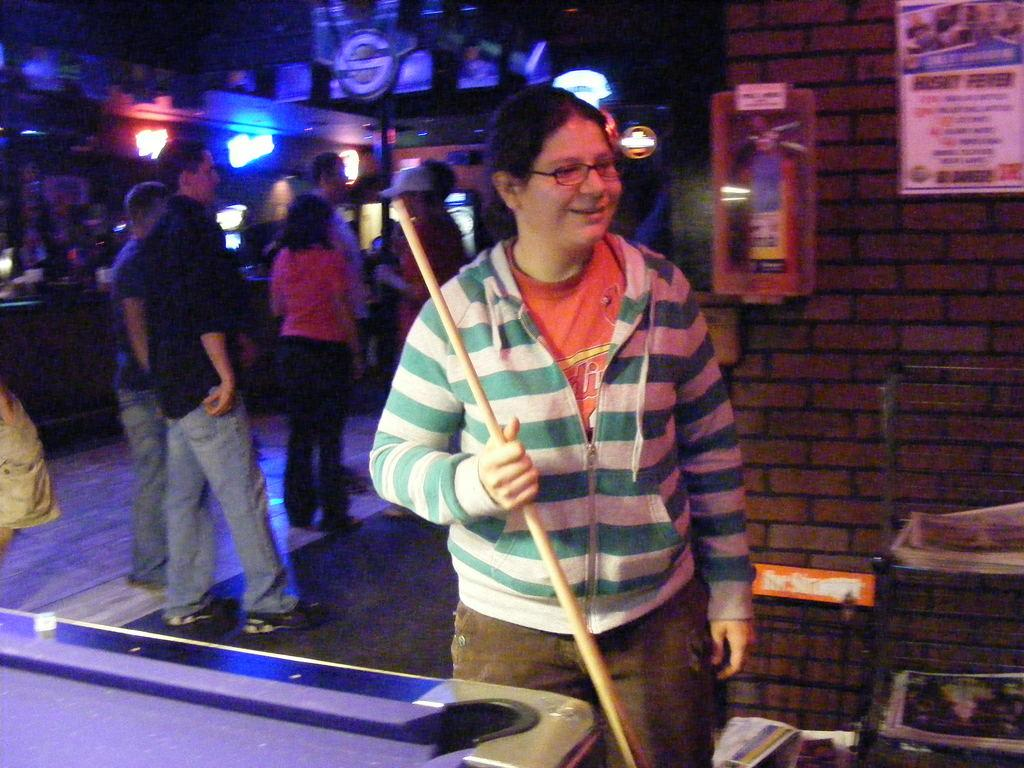Who is the main subject in the image? There is a lady in the image. What is the lady holding in her hand? The lady is holding a stick. Can you describe the lady's clothing? The lady is wearing a blue and white jacket. Are there any other people in the image? Yes, there are people standing behind the lady. What else can be seen in the image? There are lights visible in the image, and there are notes on the wall. What type of jam is being prepared by the group in the image? There is no group or jam preparation visible in the image; it features a lady holding a stick and wearing a blue and white jacket, with people standing behind her, lights visible, and notes on the wall. 